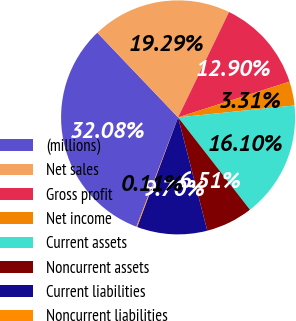Convert chart to OTSL. <chart><loc_0><loc_0><loc_500><loc_500><pie_chart><fcel>(millions)<fcel>Net sales<fcel>Gross profit<fcel>Net income<fcel>Current assets<fcel>Noncurrent assets<fcel>Current liabilities<fcel>Noncurrent liabilities<nl><fcel>32.08%<fcel>19.29%<fcel>12.9%<fcel>3.31%<fcel>16.1%<fcel>6.51%<fcel>9.7%<fcel>0.11%<nl></chart> 